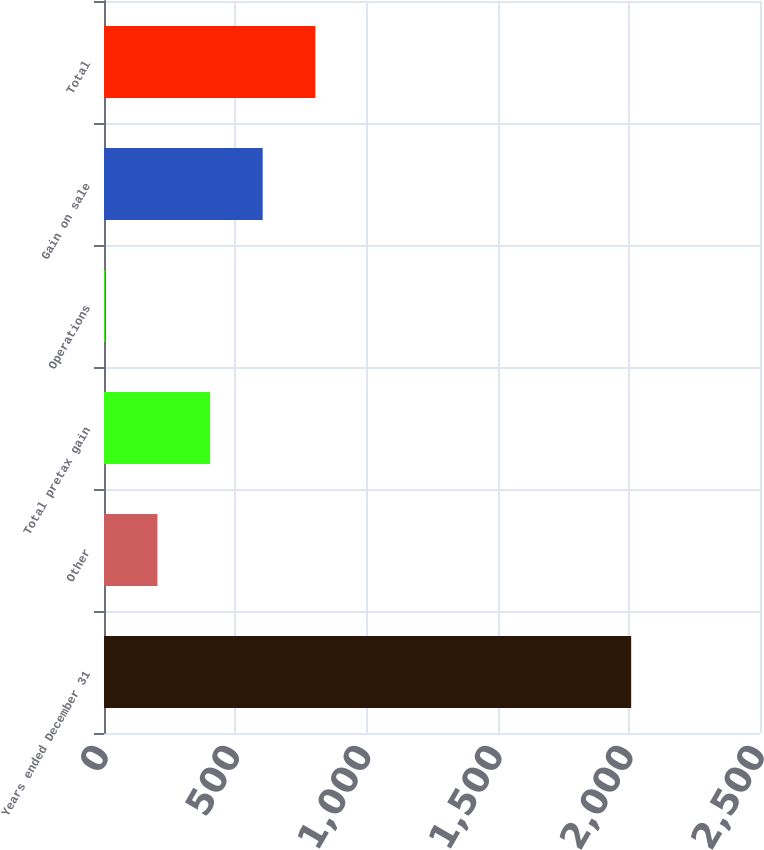<chart> <loc_0><loc_0><loc_500><loc_500><bar_chart><fcel>Years ended December 31<fcel>Other<fcel>Total pretax gain<fcel>Operations<fcel>Gain on sale<fcel>Total<nl><fcel>2009<fcel>203.6<fcel>404.2<fcel>3<fcel>604.8<fcel>805.4<nl></chart> 